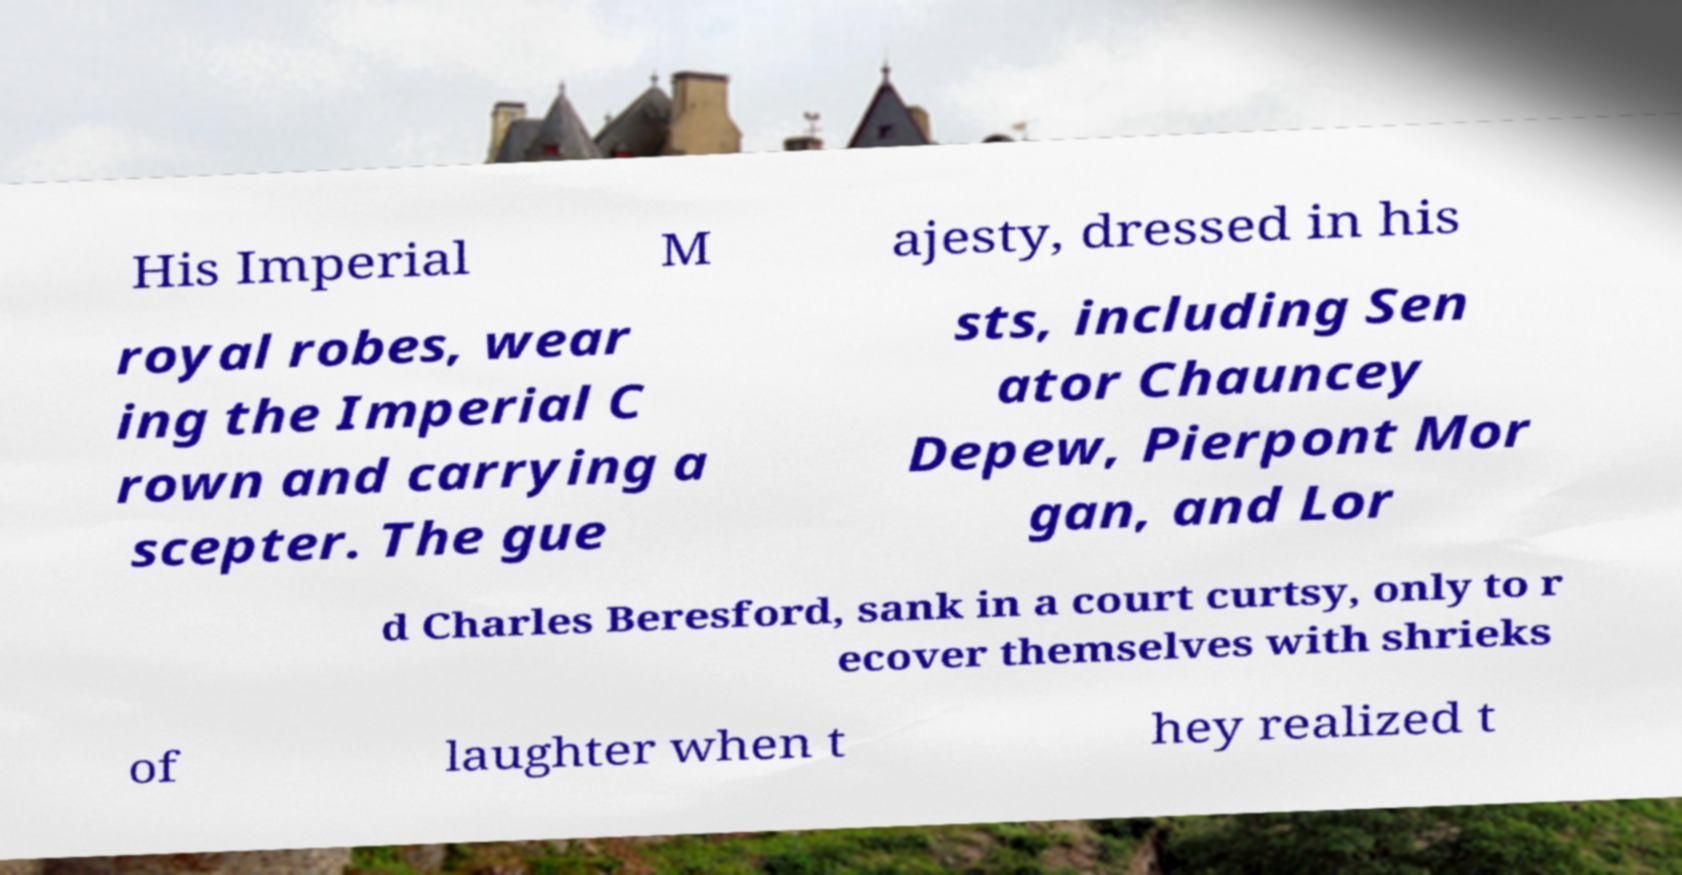Please identify and transcribe the text found in this image. His Imperial M ajesty, dressed in his royal robes, wear ing the Imperial C rown and carrying a scepter. The gue sts, including Sen ator Chauncey Depew, Pierpont Mor gan, and Lor d Charles Beresford, sank in a court curtsy, only to r ecover themselves with shrieks of laughter when t hey realized t 